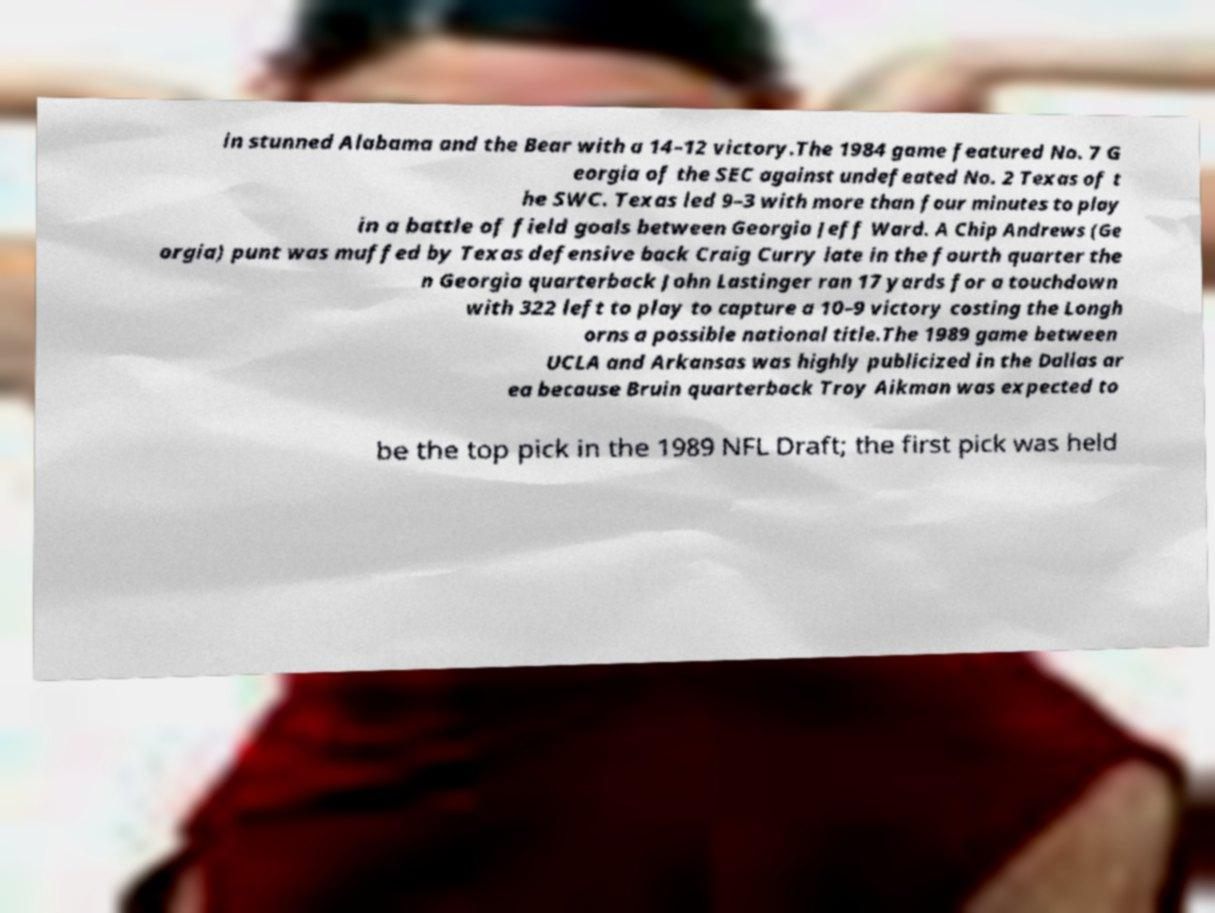Please identify and transcribe the text found in this image. in stunned Alabama and the Bear with a 14–12 victory.The 1984 game featured No. 7 G eorgia of the SEC against undefeated No. 2 Texas of t he SWC. Texas led 9–3 with more than four minutes to play in a battle of field goals between Georgia Jeff Ward. A Chip Andrews (Ge orgia) punt was muffed by Texas defensive back Craig Curry late in the fourth quarter the n Georgia quarterback John Lastinger ran 17 yards for a touchdown with 322 left to play to capture a 10–9 victory costing the Longh orns a possible national title.The 1989 game between UCLA and Arkansas was highly publicized in the Dallas ar ea because Bruin quarterback Troy Aikman was expected to be the top pick in the 1989 NFL Draft; the first pick was held 